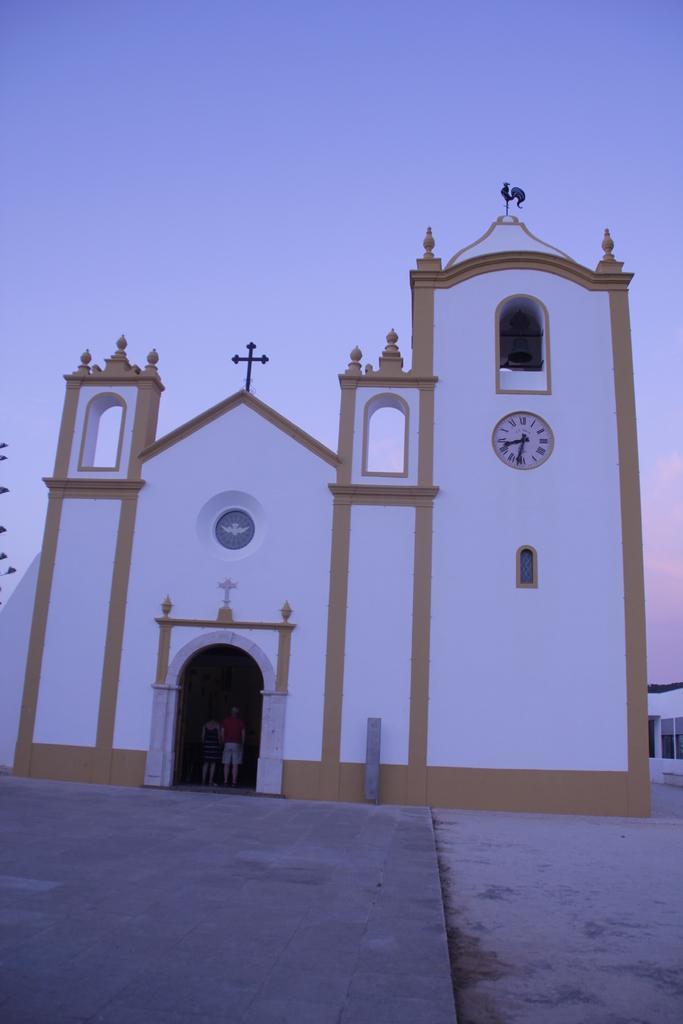Please provide a concise description of this image. In the foreground of this image, it seems like a church in the middle. At the bottom, there is pavement. On the right, there is wall and a window. At the top, there is the sky. 